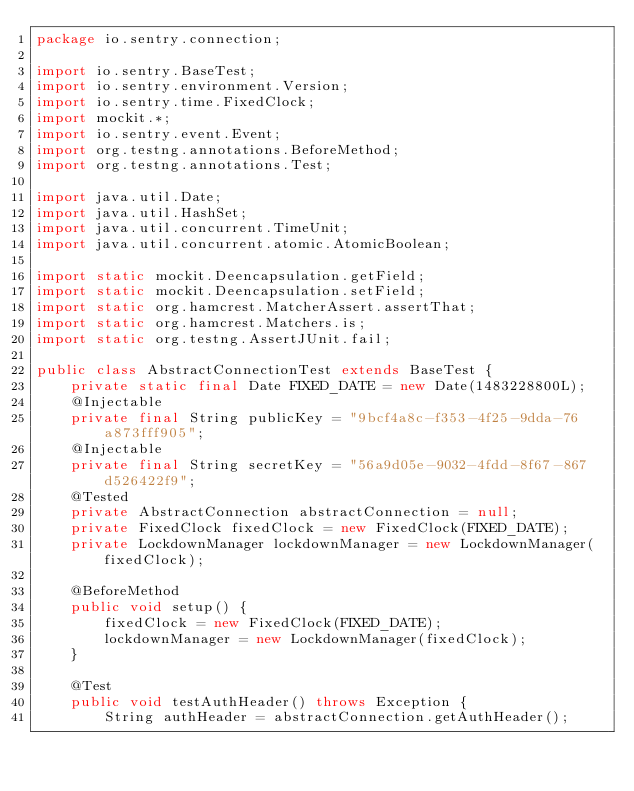<code> <loc_0><loc_0><loc_500><loc_500><_Java_>package io.sentry.connection;

import io.sentry.BaseTest;
import io.sentry.environment.Version;
import io.sentry.time.FixedClock;
import mockit.*;
import io.sentry.event.Event;
import org.testng.annotations.BeforeMethod;
import org.testng.annotations.Test;

import java.util.Date;
import java.util.HashSet;
import java.util.concurrent.TimeUnit;
import java.util.concurrent.atomic.AtomicBoolean;

import static mockit.Deencapsulation.getField;
import static mockit.Deencapsulation.setField;
import static org.hamcrest.MatcherAssert.assertThat;
import static org.hamcrest.Matchers.is;
import static org.testng.AssertJUnit.fail;

public class AbstractConnectionTest extends BaseTest {
    private static final Date FIXED_DATE = new Date(1483228800L);
    @Injectable
    private final String publicKey = "9bcf4a8c-f353-4f25-9dda-76a873fff905";
    @Injectable
    private final String secretKey = "56a9d05e-9032-4fdd-8f67-867d526422f9";
    @Tested
    private AbstractConnection abstractConnection = null;
    private FixedClock fixedClock = new FixedClock(FIXED_DATE);
    private LockdownManager lockdownManager = new LockdownManager(fixedClock);

    @BeforeMethod
    public void setup() {
        fixedClock = new FixedClock(FIXED_DATE);
        lockdownManager = new LockdownManager(fixedClock);
    }

    @Test
    public void testAuthHeader() throws Exception {
        String authHeader = abstractConnection.getAuthHeader();
</code> 